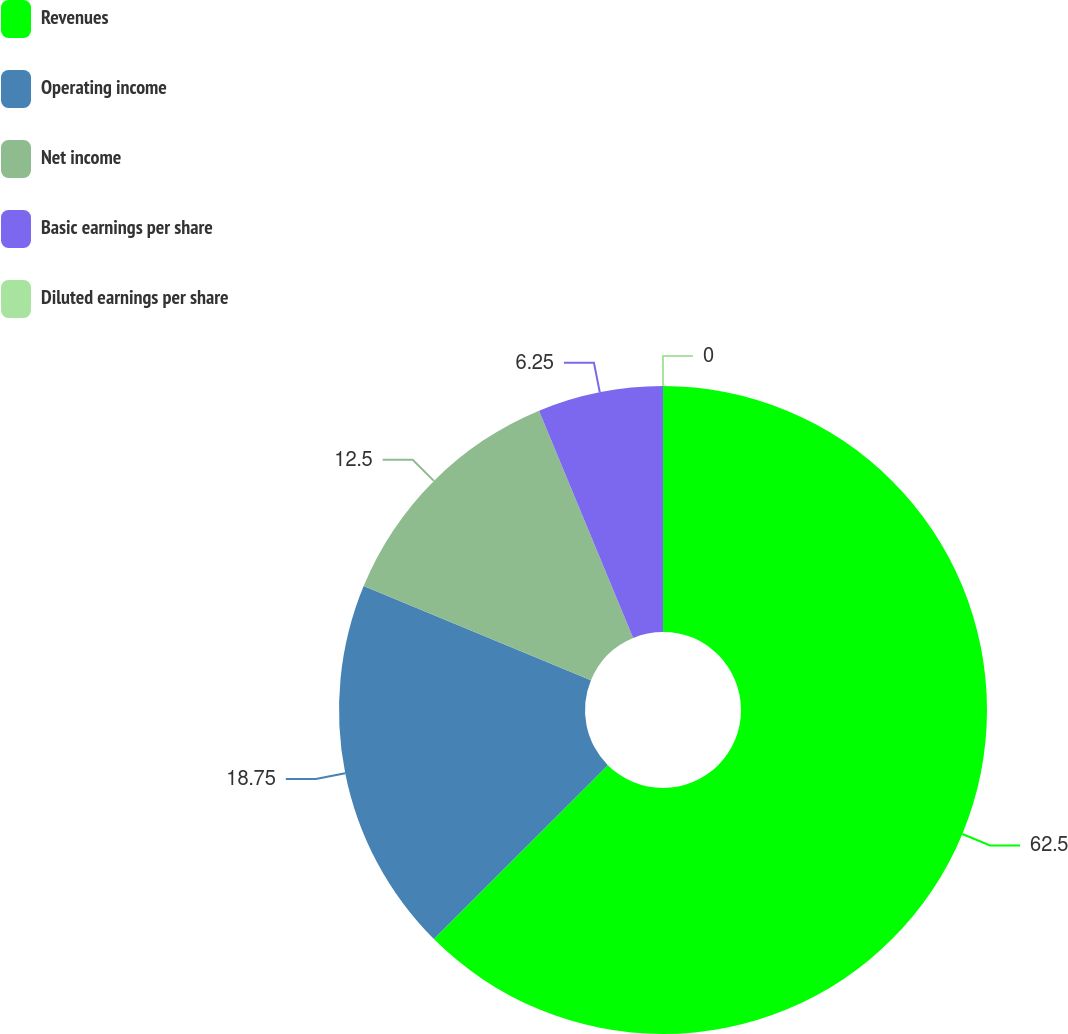<chart> <loc_0><loc_0><loc_500><loc_500><pie_chart><fcel>Revenues<fcel>Operating income<fcel>Net income<fcel>Basic earnings per share<fcel>Diluted earnings per share<nl><fcel>62.5%<fcel>18.75%<fcel>12.5%<fcel>6.25%<fcel>0.0%<nl></chart> 